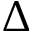Convert formula to latex. <formula><loc_0><loc_0><loc_500><loc_500>\Delta</formula> 